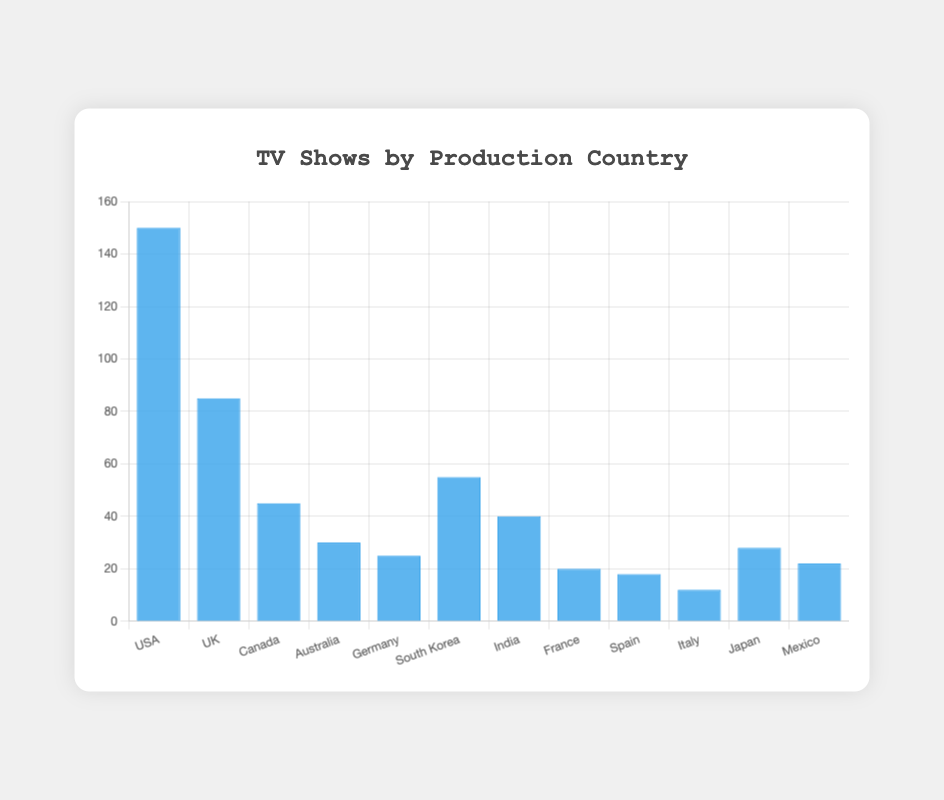Which country produces the most TV shows? The tallest bar represents the USA, indicating it produces the most TV shows.
Answer: USA Which country produces the least TV shows? The shortest bar represents Italy, indicating it produces the least TV shows.
Answer: Italy How many more TV shows does the USA produce compared to the UK? The USA produces 150 TV shows, and the UK produces 85. The difference is 150 - 85 = 65.
Answer: 65 What is the total number of TV shows produced by Canada, Australia, and Germany combined? Canada produces 45, Australia 30, and Germany 25. The total is 45 + 30 + 25 = 100.
Answer: 100 Which countries produce more than 50 TV shows? The bars for the USA (150), the UK (85), and South Korea (55) are higher than 50.
Answer: USA, UK, South Korea How many TV shows does South Korea produce in comparison to Japan? South Korea produces 55 TV shows, while Japan produces 28. The difference is 55 - 28 = 27.
Answer: 27 What is the average number of TV shows produced by the countries listed? Sum the number of TV shows for all countries: 150 + 85 + 45 + 30 + 25 + 55 + 40 + 20 + 18 + 12 + 28 + 22 = 530. There are 12 countries, so the average is 530 / 12 ≈ 44.17.
Answer: 44.17 What is the color used for the bars in the chart? All the bars in the chart are colored blue.
Answer: Blue How many TV shows are produced by European countries in the list? European countries listed are the UK (85), Germany (25), France (20), Spain (18), Italy (12). The total is 85 + 25 + 20 + 18 + 12 = 160.
Answer: 160 Which countries have between 20 and 30 TV shows? The bars for France (20), Spain (18), Japan (28), and Mexico (22) fall within this range. However, Spain narrowly misses out as it has 18.
Answer: Japan, Mexico 